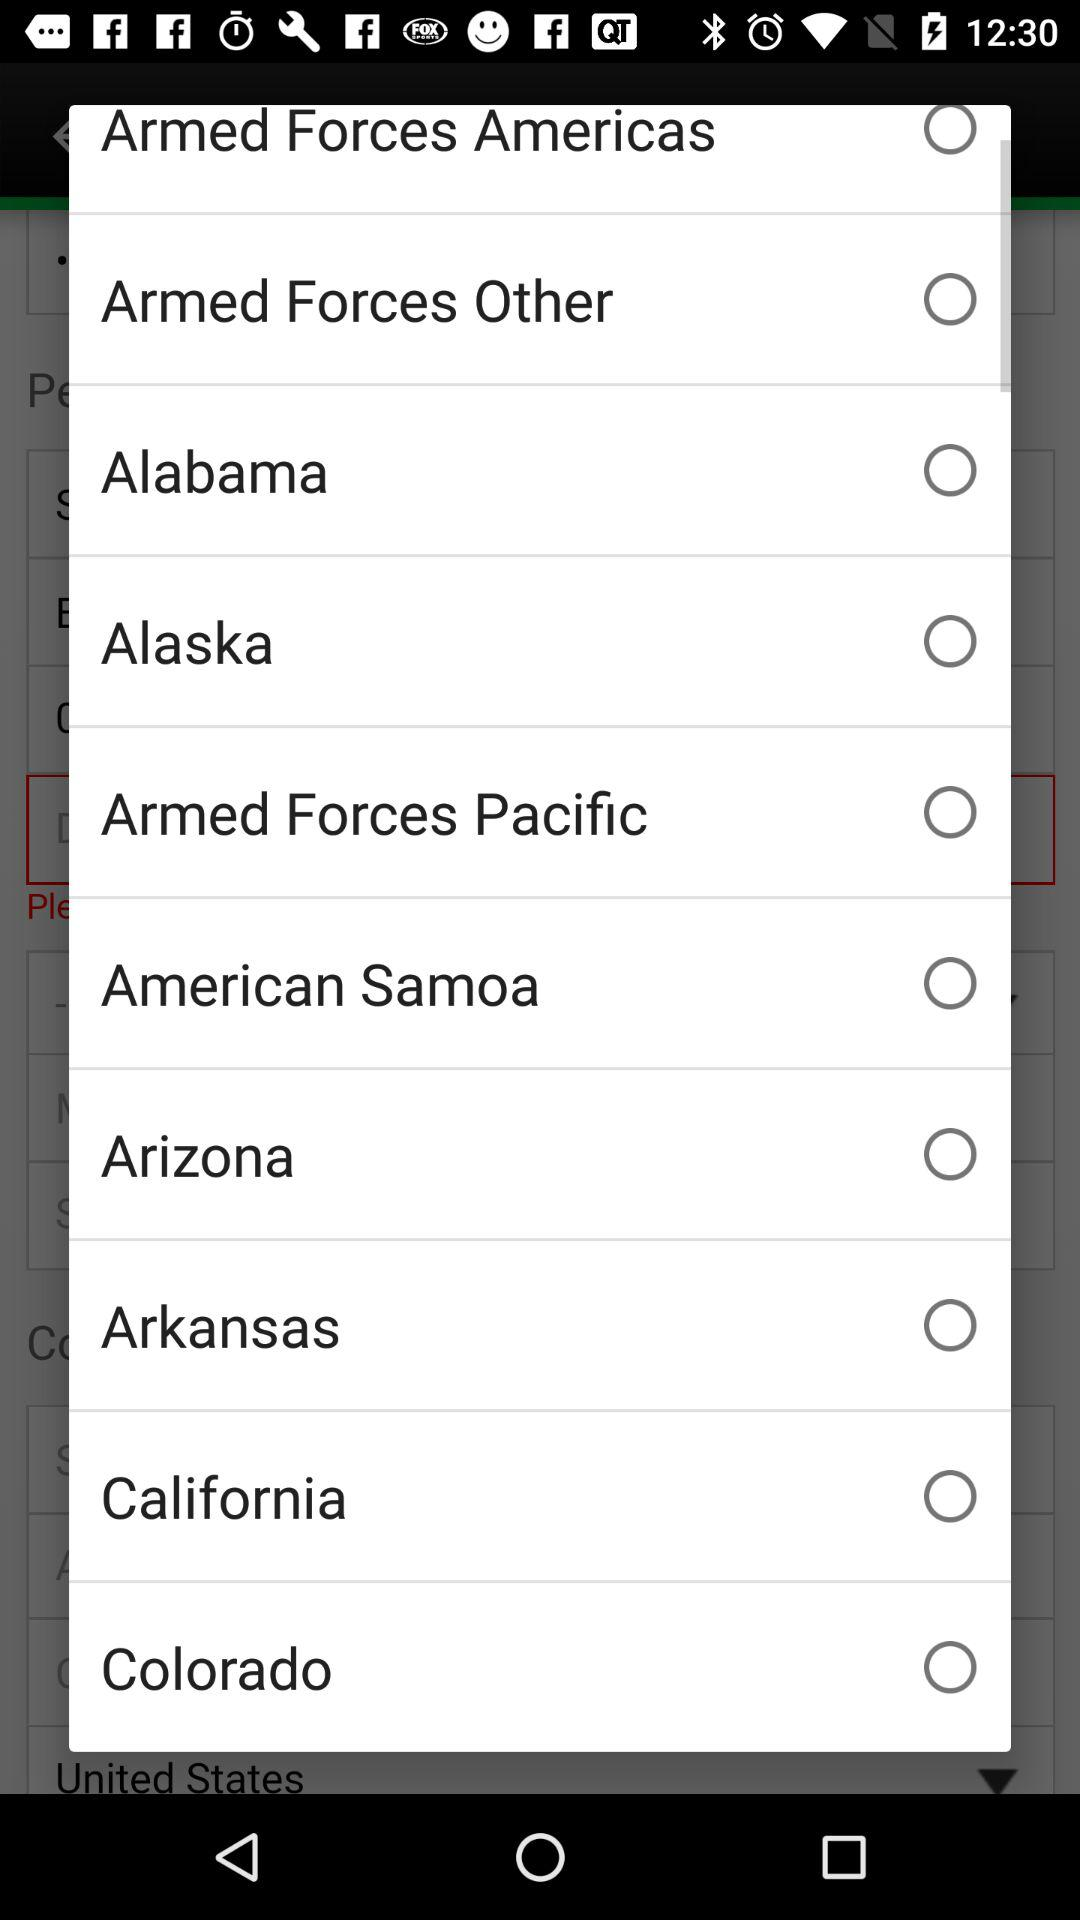Is "Arizona" selected or not? It is not selected. 